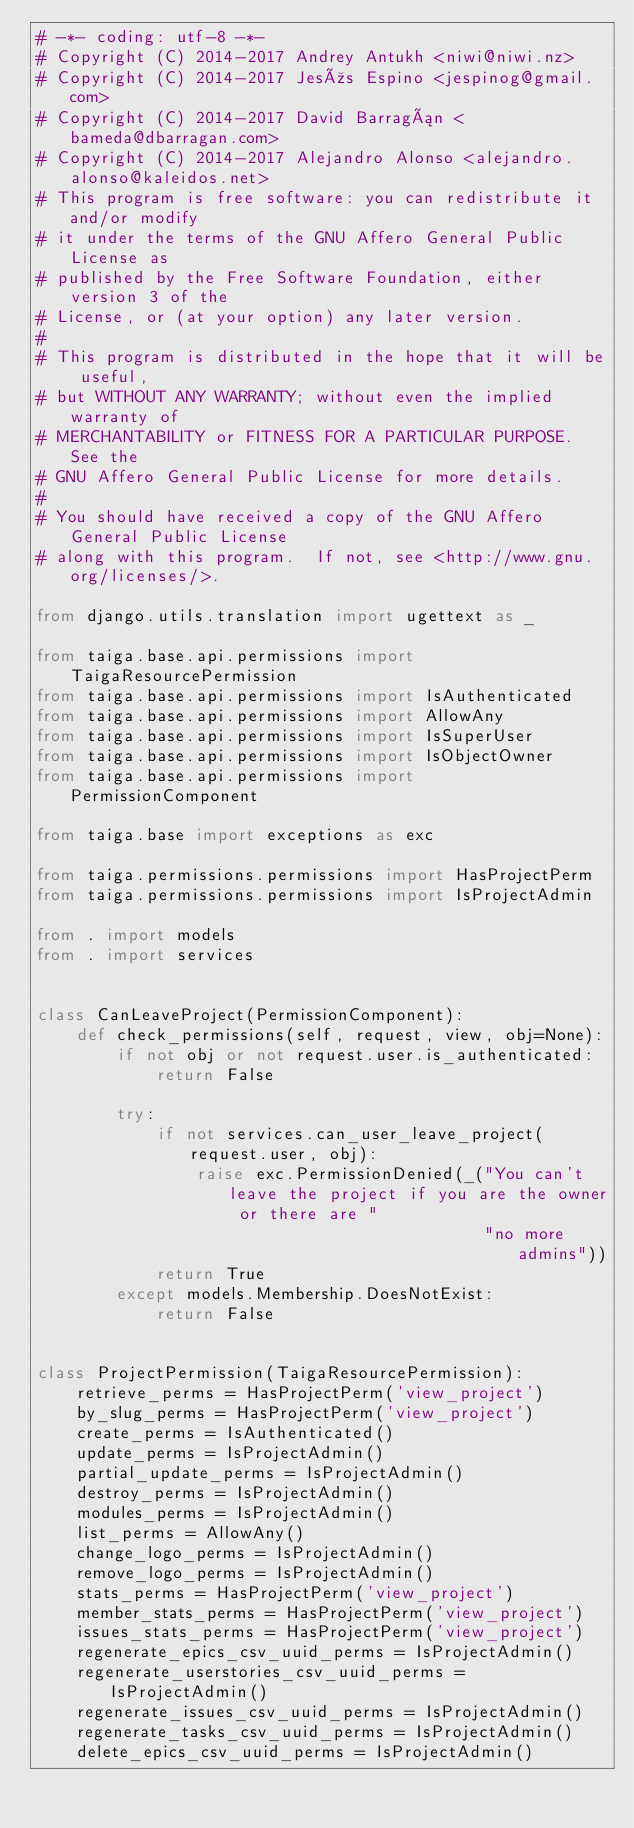<code> <loc_0><loc_0><loc_500><loc_500><_Python_># -*- coding: utf-8 -*-
# Copyright (C) 2014-2017 Andrey Antukh <niwi@niwi.nz>
# Copyright (C) 2014-2017 Jesús Espino <jespinog@gmail.com>
# Copyright (C) 2014-2017 David Barragán <bameda@dbarragan.com>
# Copyright (C) 2014-2017 Alejandro Alonso <alejandro.alonso@kaleidos.net>
# This program is free software: you can redistribute it and/or modify
# it under the terms of the GNU Affero General Public License as
# published by the Free Software Foundation, either version 3 of the
# License, or (at your option) any later version.
#
# This program is distributed in the hope that it will be useful,
# but WITHOUT ANY WARRANTY; without even the implied warranty of
# MERCHANTABILITY or FITNESS FOR A PARTICULAR PURPOSE.  See the
# GNU Affero General Public License for more details.
#
# You should have received a copy of the GNU Affero General Public License
# along with this program.  If not, see <http://www.gnu.org/licenses/>.

from django.utils.translation import ugettext as _

from taiga.base.api.permissions import TaigaResourcePermission
from taiga.base.api.permissions import IsAuthenticated
from taiga.base.api.permissions import AllowAny
from taiga.base.api.permissions import IsSuperUser
from taiga.base.api.permissions import IsObjectOwner
from taiga.base.api.permissions import PermissionComponent

from taiga.base import exceptions as exc

from taiga.permissions.permissions import HasProjectPerm
from taiga.permissions.permissions import IsProjectAdmin

from . import models
from . import services


class CanLeaveProject(PermissionComponent):
    def check_permissions(self, request, view, obj=None):
        if not obj or not request.user.is_authenticated:
            return False

        try:
            if not services.can_user_leave_project(request.user, obj):
                raise exc.PermissionDenied(_("You can't leave the project if you are the owner or there are "
                                             "no more admins"))
            return True
        except models.Membership.DoesNotExist:
            return False


class ProjectPermission(TaigaResourcePermission):
    retrieve_perms = HasProjectPerm('view_project')
    by_slug_perms = HasProjectPerm('view_project')
    create_perms = IsAuthenticated()
    update_perms = IsProjectAdmin()
    partial_update_perms = IsProjectAdmin()
    destroy_perms = IsProjectAdmin()
    modules_perms = IsProjectAdmin()
    list_perms = AllowAny()
    change_logo_perms = IsProjectAdmin()
    remove_logo_perms = IsProjectAdmin()
    stats_perms = HasProjectPerm('view_project')
    member_stats_perms = HasProjectPerm('view_project')
    issues_stats_perms = HasProjectPerm('view_project')
    regenerate_epics_csv_uuid_perms = IsProjectAdmin()
    regenerate_userstories_csv_uuid_perms = IsProjectAdmin()
    regenerate_issues_csv_uuid_perms = IsProjectAdmin()
    regenerate_tasks_csv_uuid_perms = IsProjectAdmin()
    delete_epics_csv_uuid_perms = IsProjectAdmin()</code> 